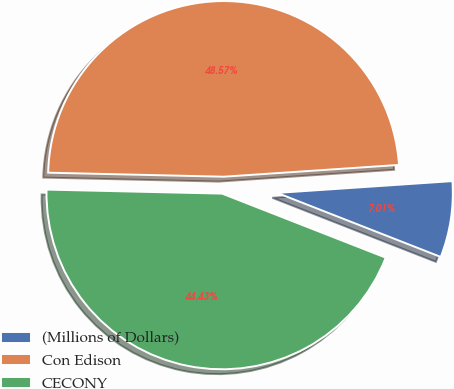<chart> <loc_0><loc_0><loc_500><loc_500><pie_chart><fcel>(Millions of Dollars)<fcel>Con Edison<fcel>CECONY<nl><fcel>7.01%<fcel>48.57%<fcel>44.43%<nl></chart> 